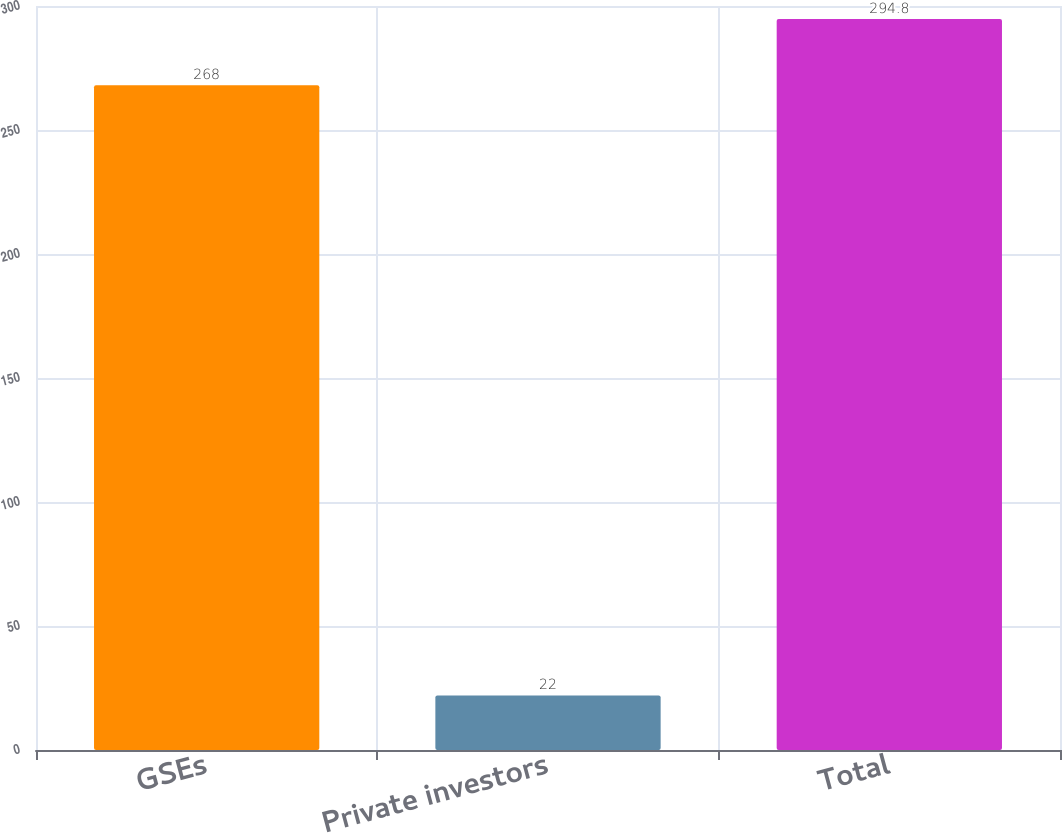Convert chart. <chart><loc_0><loc_0><loc_500><loc_500><bar_chart><fcel>GSEs<fcel>Private investors<fcel>Total<nl><fcel>268<fcel>22<fcel>294.8<nl></chart> 